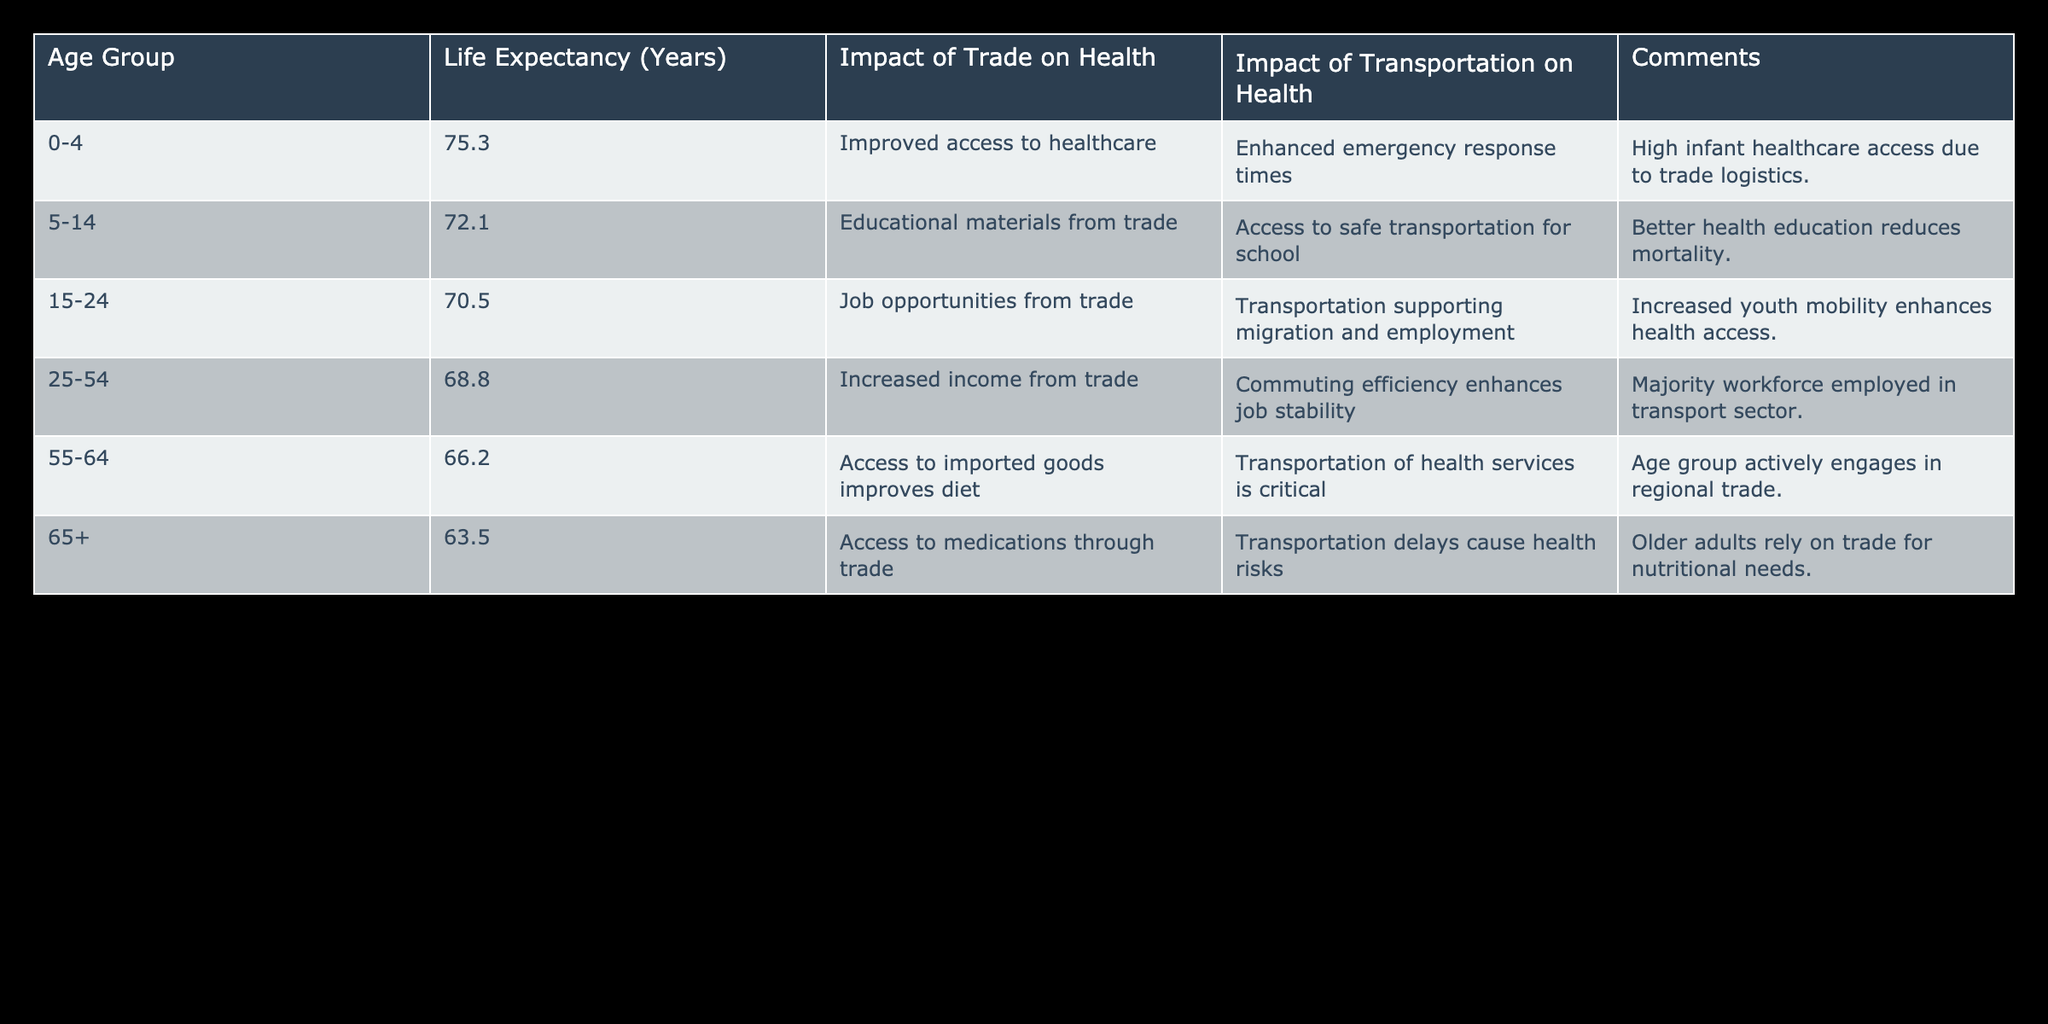What is the life expectancy for the 0-4 age group? According to the table, the life expectancy for the 0-4 age group is listed directly as 75.3 years.
Answer: 75.3 years What is the life expectancy for the 65+ age group? The table shows that the life expectancy for the 65+ age group is 63.5 years.
Answer: 63.5 years Which age group has the highest life expectancy, and what is that value? The 0-4 age group has the highest life expectancy at 75.3 years, as seen in the Life Expectancy column.
Answer: 0-4 age group, 75.3 years What is the average life expectancy across all age groups provided in the table? To find the average, sum the life expectancies: 75.3 + 72.1 + 70.5 + 68.8 + 66.2 + 63.5 = 416.4. There are 6 groups, so divide 416.4 by 6, which gives approximately 69.4 years.
Answer: 69.4 years Do individuals aged 25-54 benefit from increased income due to trade? Yes, according to the table, the impact of trade on the 25-54 age group includes increased income.
Answer: Yes Is transportation mentioned as a critical factor for health in the age group 55-64? Yes, the table indicates that transportation of health services is critical for the 55-64 age group.
Answer: Yes Does the life expectancy decrease with age according to the table? Yes, from the table, we can observe that life expectancy decreases as the age group increases (e.g., from 75.3 for 0-4 to 63.5 for 65+).
Answer: Yes Which age group relies on trade for nutritional needs? The table states that older adults (65+) rely on trade for nutritional needs, as mentioned in the comments.
Answer: 65+ age group What can you conclude about the impact of transportation on health for those aged 15-24? For the 15-24 age group, transportation supports migration and employment, indicating that it has a positive impact on health access for this group.
Answer: Positive impact How much does the life expectancy for the age group 25-54 differ from that of the 55-64 age group? The life expectancy for the 25-54 age group is 68.8 years, while for the 55-64 age group, it is 66.2 years. The difference is 68.8 - 66.2 = 2.6 years.
Answer: 2.6 years 